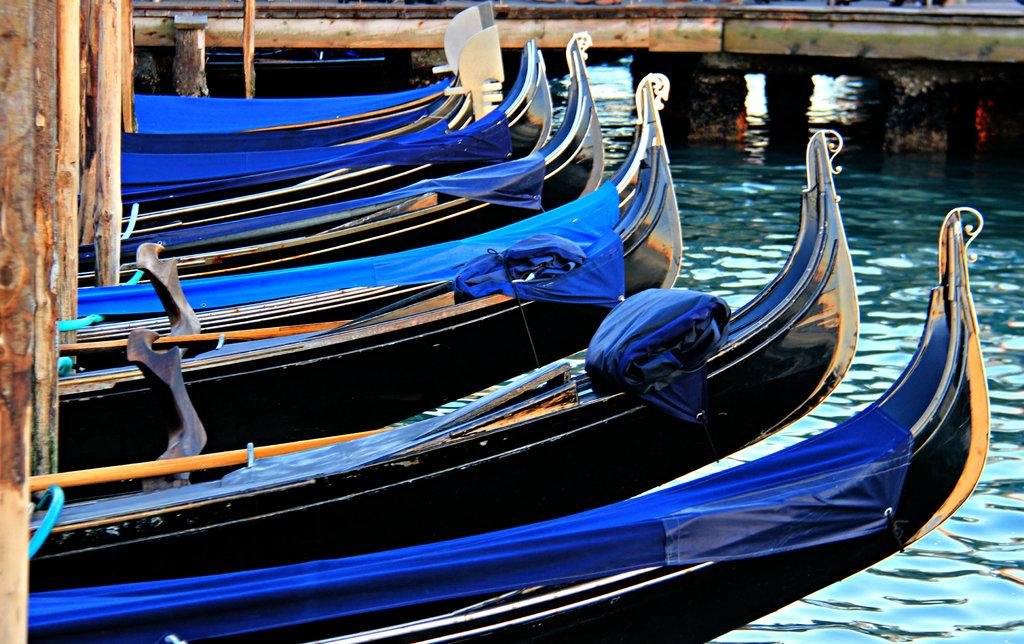What type of vehicles are in the water in the image? There are boats in the water in the image. What is the wooden pole in the image used for? The purpose of the wooden pole in the image is not specified, but it could be used for mooring or as a marker. What is the primary element visible in the image? Water is the primary element visible in the image. What are the paddles used for in the image? The paddles are likely used for propelling the boats in the water. What type of feast is being held on the boats in the image? There is no indication of a feast being held on the boats in the image. What tax is being collected from the boats in the image? There is no indication of any tax being collected from the boats in the image. 